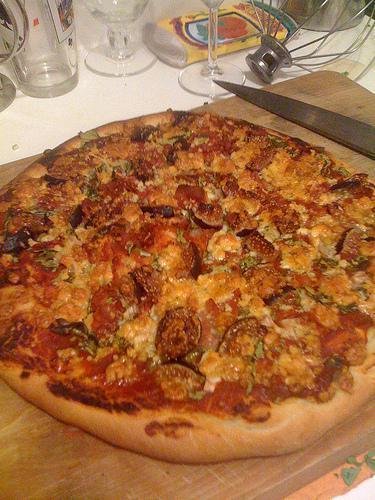How many pizzas are there?
Give a very brief answer. 1. 